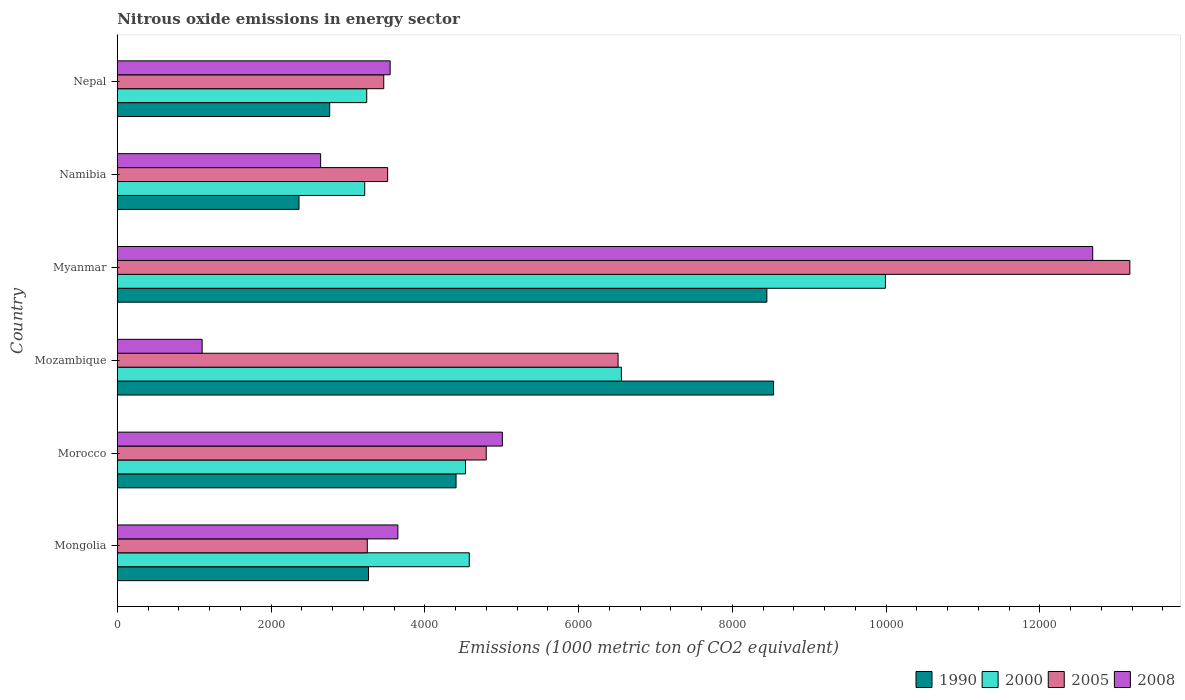How many different coloured bars are there?
Your answer should be very brief. 4. How many bars are there on the 3rd tick from the top?
Make the answer very short. 4. How many bars are there on the 5th tick from the bottom?
Make the answer very short. 4. What is the label of the 2nd group of bars from the top?
Provide a succinct answer. Namibia. What is the amount of nitrous oxide emitted in 1990 in Myanmar?
Make the answer very short. 8449.7. Across all countries, what is the maximum amount of nitrous oxide emitted in 2008?
Make the answer very short. 1.27e+04. Across all countries, what is the minimum amount of nitrous oxide emitted in 2008?
Provide a succinct answer. 1104.1. In which country was the amount of nitrous oxide emitted in 2000 maximum?
Give a very brief answer. Myanmar. In which country was the amount of nitrous oxide emitted in 2008 minimum?
Offer a terse response. Mozambique. What is the total amount of nitrous oxide emitted in 2008 in the graph?
Provide a short and direct response. 2.86e+04. What is the difference between the amount of nitrous oxide emitted in 2000 in Mongolia and that in Namibia?
Offer a very short reply. 1359.9. What is the difference between the amount of nitrous oxide emitted in 2008 in Myanmar and the amount of nitrous oxide emitted in 2005 in Nepal?
Your response must be concise. 9222.3. What is the average amount of nitrous oxide emitted in 2000 per country?
Your response must be concise. 5353.5. What is the difference between the amount of nitrous oxide emitted in 2000 and amount of nitrous oxide emitted in 1990 in Morocco?
Your answer should be very brief. 122.6. In how many countries, is the amount of nitrous oxide emitted in 1990 greater than 11600 1000 metric ton?
Give a very brief answer. 0. What is the ratio of the amount of nitrous oxide emitted in 1990 in Morocco to that in Myanmar?
Offer a terse response. 0.52. Is the amount of nitrous oxide emitted in 2000 in Morocco less than that in Namibia?
Your answer should be compact. No. What is the difference between the highest and the second highest amount of nitrous oxide emitted in 2005?
Your answer should be very brief. 6657.4. What is the difference between the highest and the lowest amount of nitrous oxide emitted in 2000?
Provide a succinct answer. 6773.5. In how many countries, is the amount of nitrous oxide emitted in 1990 greater than the average amount of nitrous oxide emitted in 1990 taken over all countries?
Make the answer very short. 2. Is it the case that in every country, the sum of the amount of nitrous oxide emitted in 2008 and amount of nitrous oxide emitted in 2005 is greater than the sum of amount of nitrous oxide emitted in 1990 and amount of nitrous oxide emitted in 2000?
Keep it short and to the point. No. What does the 2nd bar from the top in Mongolia represents?
Your answer should be compact. 2005. What does the 2nd bar from the bottom in Mozambique represents?
Give a very brief answer. 2000. How many bars are there?
Your response must be concise. 24. Are all the bars in the graph horizontal?
Offer a terse response. Yes. How many countries are there in the graph?
Provide a short and direct response. 6. What is the difference between two consecutive major ticks on the X-axis?
Your response must be concise. 2000. Are the values on the major ticks of X-axis written in scientific E-notation?
Provide a short and direct response. No. Does the graph contain grids?
Provide a succinct answer. No. Where does the legend appear in the graph?
Your answer should be compact. Bottom right. How are the legend labels stacked?
Offer a very short reply. Horizontal. What is the title of the graph?
Offer a very short reply. Nitrous oxide emissions in energy sector. Does "2001" appear as one of the legend labels in the graph?
Give a very brief answer. No. What is the label or title of the X-axis?
Keep it short and to the point. Emissions (1000 metric ton of CO2 equivalent). What is the label or title of the Y-axis?
Give a very brief answer. Country. What is the Emissions (1000 metric ton of CO2 equivalent) in 1990 in Mongolia?
Offer a very short reply. 3267.8. What is the Emissions (1000 metric ton of CO2 equivalent) in 2000 in Mongolia?
Ensure brevity in your answer.  4578.6. What is the Emissions (1000 metric ton of CO2 equivalent) of 2005 in Mongolia?
Ensure brevity in your answer.  3251.9. What is the Emissions (1000 metric ton of CO2 equivalent) in 2008 in Mongolia?
Provide a short and direct response. 3650.1. What is the Emissions (1000 metric ton of CO2 equivalent) of 1990 in Morocco?
Make the answer very short. 4406.9. What is the Emissions (1000 metric ton of CO2 equivalent) of 2000 in Morocco?
Give a very brief answer. 4529.5. What is the Emissions (1000 metric ton of CO2 equivalent) in 2005 in Morocco?
Keep it short and to the point. 4799.4. What is the Emissions (1000 metric ton of CO2 equivalent) of 2008 in Morocco?
Give a very brief answer. 5008.9. What is the Emissions (1000 metric ton of CO2 equivalent) in 1990 in Mozambique?
Make the answer very short. 8537. What is the Emissions (1000 metric ton of CO2 equivalent) of 2000 in Mozambique?
Provide a short and direct response. 6557.2. What is the Emissions (1000 metric ton of CO2 equivalent) of 2005 in Mozambique?
Your response must be concise. 6514.2. What is the Emissions (1000 metric ton of CO2 equivalent) of 2008 in Mozambique?
Keep it short and to the point. 1104.1. What is the Emissions (1000 metric ton of CO2 equivalent) of 1990 in Myanmar?
Provide a short and direct response. 8449.7. What is the Emissions (1000 metric ton of CO2 equivalent) in 2000 in Myanmar?
Keep it short and to the point. 9992.2. What is the Emissions (1000 metric ton of CO2 equivalent) in 2005 in Myanmar?
Make the answer very short. 1.32e+04. What is the Emissions (1000 metric ton of CO2 equivalent) of 2008 in Myanmar?
Provide a succinct answer. 1.27e+04. What is the Emissions (1000 metric ton of CO2 equivalent) of 1990 in Namibia?
Your answer should be compact. 2363.8. What is the Emissions (1000 metric ton of CO2 equivalent) of 2000 in Namibia?
Your answer should be compact. 3218.7. What is the Emissions (1000 metric ton of CO2 equivalent) of 2005 in Namibia?
Offer a terse response. 3516.8. What is the Emissions (1000 metric ton of CO2 equivalent) of 2008 in Namibia?
Provide a succinct answer. 2645.5. What is the Emissions (1000 metric ton of CO2 equivalent) of 1990 in Nepal?
Offer a very short reply. 2763. What is the Emissions (1000 metric ton of CO2 equivalent) in 2000 in Nepal?
Ensure brevity in your answer.  3244.8. What is the Emissions (1000 metric ton of CO2 equivalent) in 2005 in Nepal?
Your answer should be compact. 3466.2. What is the Emissions (1000 metric ton of CO2 equivalent) of 2008 in Nepal?
Your answer should be very brief. 3549.4. Across all countries, what is the maximum Emissions (1000 metric ton of CO2 equivalent) of 1990?
Your answer should be compact. 8537. Across all countries, what is the maximum Emissions (1000 metric ton of CO2 equivalent) in 2000?
Your answer should be compact. 9992.2. Across all countries, what is the maximum Emissions (1000 metric ton of CO2 equivalent) in 2005?
Provide a short and direct response. 1.32e+04. Across all countries, what is the maximum Emissions (1000 metric ton of CO2 equivalent) in 2008?
Your response must be concise. 1.27e+04. Across all countries, what is the minimum Emissions (1000 metric ton of CO2 equivalent) of 1990?
Make the answer very short. 2363.8. Across all countries, what is the minimum Emissions (1000 metric ton of CO2 equivalent) in 2000?
Give a very brief answer. 3218.7. Across all countries, what is the minimum Emissions (1000 metric ton of CO2 equivalent) of 2005?
Your response must be concise. 3251.9. Across all countries, what is the minimum Emissions (1000 metric ton of CO2 equivalent) in 2008?
Keep it short and to the point. 1104.1. What is the total Emissions (1000 metric ton of CO2 equivalent) in 1990 in the graph?
Give a very brief answer. 2.98e+04. What is the total Emissions (1000 metric ton of CO2 equivalent) in 2000 in the graph?
Provide a short and direct response. 3.21e+04. What is the total Emissions (1000 metric ton of CO2 equivalent) of 2005 in the graph?
Provide a succinct answer. 3.47e+04. What is the total Emissions (1000 metric ton of CO2 equivalent) of 2008 in the graph?
Give a very brief answer. 2.86e+04. What is the difference between the Emissions (1000 metric ton of CO2 equivalent) in 1990 in Mongolia and that in Morocco?
Your answer should be compact. -1139.1. What is the difference between the Emissions (1000 metric ton of CO2 equivalent) of 2000 in Mongolia and that in Morocco?
Your answer should be very brief. 49.1. What is the difference between the Emissions (1000 metric ton of CO2 equivalent) in 2005 in Mongolia and that in Morocco?
Offer a very short reply. -1547.5. What is the difference between the Emissions (1000 metric ton of CO2 equivalent) of 2008 in Mongolia and that in Morocco?
Offer a very short reply. -1358.8. What is the difference between the Emissions (1000 metric ton of CO2 equivalent) of 1990 in Mongolia and that in Mozambique?
Give a very brief answer. -5269.2. What is the difference between the Emissions (1000 metric ton of CO2 equivalent) of 2000 in Mongolia and that in Mozambique?
Offer a terse response. -1978.6. What is the difference between the Emissions (1000 metric ton of CO2 equivalent) of 2005 in Mongolia and that in Mozambique?
Give a very brief answer. -3262.3. What is the difference between the Emissions (1000 metric ton of CO2 equivalent) of 2008 in Mongolia and that in Mozambique?
Provide a succinct answer. 2546. What is the difference between the Emissions (1000 metric ton of CO2 equivalent) in 1990 in Mongolia and that in Myanmar?
Offer a terse response. -5181.9. What is the difference between the Emissions (1000 metric ton of CO2 equivalent) of 2000 in Mongolia and that in Myanmar?
Provide a succinct answer. -5413.6. What is the difference between the Emissions (1000 metric ton of CO2 equivalent) of 2005 in Mongolia and that in Myanmar?
Offer a very short reply. -9919.7. What is the difference between the Emissions (1000 metric ton of CO2 equivalent) of 2008 in Mongolia and that in Myanmar?
Keep it short and to the point. -9038.4. What is the difference between the Emissions (1000 metric ton of CO2 equivalent) in 1990 in Mongolia and that in Namibia?
Ensure brevity in your answer.  904. What is the difference between the Emissions (1000 metric ton of CO2 equivalent) of 2000 in Mongolia and that in Namibia?
Provide a short and direct response. 1359.9. What is the difference between the Emissions (1000 metric ton of CO2 equivalent) of 2005 in Mongolia and that in Namibia?
Your response must be concise. -264.9. What is the difference between the Emissions (1000 metric ton of CO2 equivalent) in 2008 in Mongolia and that in Namibia?
Ensure brevity in your answer.  1004.6. What is the difference between the Emissions (1000 metric ton of CO2 equivalent) of 1990 in Mongolia and that in Nepal?
Provide a succinct answer. 504.8. What is the difference between the Emissions (1000 metric ton of CO2 equivalent) of 2000 in Mongolia and that in Nepal?
Keep it short and to the point. 1333.8. What is the difference between the Emissions (1000 metric ton of CO2 equivalent) of 2005 in Mongolia and that in Nepal?
Keep it short and to the point. -214.3. What is the difference between the Emissions (1000 metric ton of CO2 equivalent) of 2008 in Mongolia and that in Nepal?
Keep it short and to the point. 100.7. What is the difference between the Emissions (1000 metric ton of CO2 equivalent) of 1990 in Morocco and that in Mozambique?
Make the answer very short. -4130.1. What is the difference between the Emissions (1000 metric ton of CO2 equivalent) in 2000 in Morocco and that in Mozambique?
Offer a very short reply. -2027.7. What is the difference between the Emissions (1000 metric ton of CO2 equivalent) of 2005 in Morocco and that in Mozambique?
Your answer should be very brief. -1714.8. What is the difference between the Emissions (1000 metric ton of CO2 equivalent) in 2008 in Morocco and that in Mozambique?
Keep it short and to the point. 3904.8. What is the difference between the Emissions (1000 metric ton of CO2 equivalent) of 1990 in Morocco and that in Myanmar?
Keep it short and to the point. -4042.8. What is the difference between the Emissions (1000 metric ton of CO2 equivalent) in 2000 in Morocco and that in Myanmar?
Keep it short and to the point. -5462.7. What is the difference between the Emissions (1000 metric ton of CO2 equivalent) in 2005 in Morocco and that in Myanmar?
Offer a very short reply. -8372.2. What is the difference between the Emissions (1000 metric ton of CO2 equivalent) of 2008 in Morocco and that in Myanmar?
Ensure brevity in your answer.  -7679.6. What is the difference between the Emissions (1000 metric ton of CO2 equivalent) in 1990 in Morocco and that in Namibia?
Ensure brevity in your answer.  2043.1. What is the difference between the Emissions (1000 metric ton of CO2 equivalent) in 2000 in Morocco and that in Namibia?
Your answer should be compact. 1310.8. What is the difference between the Emissions (1000 metric ton of CO2 equivalent) in 2005 in Morocco and that in Namibia?
Your answer should be compact. 1282.6. What is the difference between the Emissions (1000 metric ton of CO2 equivalent) of 2008 in Morocco and that in Namibia?
Offer a very short reply. 2363.4. What is the difference between the Emissions (1000 metric ton of CO2 equivalent) of 1990 in Morocco and that in Nepal?
Keep it short and to the point. 1643.9. What is the difference between the Emissions (1000 metric ton of CO2 equivalent) in 2000 in Morocco and that in Nepal?
Keep it short and to the point. 1284.7. What is the difference between the Emissions (1000 metric ton of CO2 equivalent) in 2005 in Morocco and that in Nepal?
Offer a very short reply. 1333.2. What is the difference between the Emissions (1000 metric ton of CO2 equivalent) in 2008 in Morocco and that in Nepal?
Your answer should be compact. 1459.5. What is the difference between the Emissions (1000 metric ton of CO2 equivalent) of 1990 in Mozambique and that in Myanmar?
Make the answer very short. 87.3. What is the difference between the Emissions (1000 metric ton of CO2 equivalent) in 2000 in Mozambique and that in Myanmar?
Give a very brief answer. -3435. What is the difference between the Emissions (1000 metric ton of CO2 equivalent) in 2005 in Mozambique and that in Myanmar?
Provide a succinct answer. -6657.4. What is the difference between the Emissions (1000 metric ton of CO2 equivalent) of 2008 in Mozambique and that in Myanmar?
Your answer should be compact. -1.16e+04. What is the difference between the Emissions (1000 metric ton of CO2 equivalent) of 1990 in Mozambique and that in Namibia?
Your response must be concise. 6173.2. What is the difference between the Emissions (1000 metric ton of CO2 equivalent) in 2000 in Mozambique and that in Namibia?
Your answer should be very brief. 3338.5. What is the difference between the Emissions (1000 metric ton of CO2 equivalent) of 2005 in Mozambique and that in Namibia?
Offer a very short reply. 2997.4. What is the difference between the Emissions (1000 metric ton of CO2 equivalent) of 2008 in Mozambique and that in Namibia?
Provide a short and direct response. -1541.4. What is the difference between the Emissions (1000 metric ton of CO2 equivalent) of 1990 in Mozambique and that in Nepal?
Offer a very short reply. 5774. What is the difference between the Emissions (1000 metric ton of CO2 equivalent) in 2000 in Mozambique and that in Nepal?
Keep it short and to the point. 3312.4. What is the difference between the Emissions (1000 metric ton of CO2 equivalent) of 2005 in Mozambique and that in Nepal?
Keep it short and to the point. 3048. What is the difference between the Emissions (1000 metric ton of CO2 equivalent) of 2008 in Mozambique and that in Nepal?
Offer a terse response. -2445.3. What is the difference between the Emissions (1000 metric ton of CO2 equivalent) in 1990 in Myanmar and that in Namibia?
Provide a succinct answer. 6085.9. What is the difference between the Emissions (1000 metric ton of CO2 equivalent) of 2000 in Myanmar and that in Namibia?
Offer a terse response. 6773.5. What is the difference between the Emissions (1000 metric ton of CO2 equivalent) of 2005 in Myanmar and that in Namibia?
Your answer should be compact. 9654.8. What is the difference between the Emissions (1000 metric ton of CO2 equivalent) in 2008 in Myanmar and that in Namibia?
Keep it short and to the point. 1.00e+04. What is the difference between the Emissions (1000 metric ton of CO2 equivalent) of 1990 in Myanmar and that in Nepal?
Your answer should be compact. 5686.7. What is the difference between the Emissions (1000 metric ton of CO2 equivalent) in 2000 in Myanmar and that in Nepal?
Your answer should be compact. 6747.4. What is the difference between the Emissions (1000 metric ton of CO2 equivalent) in 2005 in Myanmar and that in Nepal?
Offer a very short reply. 9705.4. What is the difference between the Emissions (1000 metric ton of CO2 equivalent) in 2008 in Myanmar and that in Nepal?
Offer a terse response. 9139.1. What is the difference between the Emissions (1000 metric ton of CO2 equivalent) in 1990 in Namibia and that in Nepal?
Give a very brief answer. -399.2. What is the difference between the Emissions (1000 metric ton of CO2 equivalent) of 2000 in Namibia and that in Nepal?
Your response must be concise. -26.1. What is the difference between the Emissions (1000 metric ton of CO2 equivalent) in 2005 in Namibia and that in Nepal?
Give a very brief answer. 50.6. What is the difference between the Emissions (1000 metric ton of CO2 equivalent) of 2008 in Namibia and that in Nepal?
Offer a very short reply. -903.9. What is the difference between the Emissions (1000 metric ton of CO2 equivalent) of 1990 in Mongolia and the Emissions (1000 metric ton of CO2 equivalent) of 2000 in Morocco?
Make the answer very short. -1261.7. What is the difference between the Emissions (1000 metric ton of CO2 equivalent) in 1990 in Mongolia and the Emissions (1000 metric ton of CO2 equivalent) in 2005 in Morocco?
Give a very brief answer. -1531.6. What is the difference between the Emissions (1000 metric ton of CO2 equivalent) of 1990 in Mongolia and the Emissions (1000 metric ton of CO2 equivalent) of 2008 in Morocco?
Your response must be concise. -1741.1. What is the difference between the Emissions (1000 metric ton of CO2 equivalent) in 2000 in Mongolia and the Emissions (1000 metric ton of CO2 equivalent) in 2005 in Morocco?
Keep it short and to the point. -220.8. What is the difference between the Emissions (1000 metric ton of CO2 equivalent) in 2000 in Mongolia and the Emissions (1000 metric ton of CO2 equivalent) in 2008 in Morocco?
Provide a succinct answer. -430.3. What is the difference between the Emissions (1000 metric ton of CO2 equivalent) in 2005 in Mongolia and the Emissions (1000 metric ton of CO2 equivalent) in 2008 in Morocco?
Your answer should be compact. -1757. What is the difference between the Emissions (1000 metric ton of CO2 equivalent) in 1990 in Mongolia and the Emissions (1000 metric ton of CO2 equivalent) in 2000 in Mozambique?
Keep it short and to the point. -3289.4. What is the difference between the Emissions (1000 metric ton of CO2 equivalent) of 1990 in Mongolia and the Emissions (1000 metric ton of CO2 equivalent) of 2005 in Mozambique?
Make the answer very short. -3246.4. What is the difference between the Emissions (1000 metric ton of CO2 equivalent) of 1990 in Mongolia and the Emissions (1000 metric ton of CO2 equivalent) of 2008 in Mozambique?
Offer a terse response. 2163.7. What is the difference between the Emissions (1000 metric ton of CO2 equivalent) in 2000 in Mongolia and the Emissions (1000 metric ton of CO2 equivalent) in 2005 in Mozambique?
Ensure brevity in your answer.  -1935.6. What is the difference between the Emissions (1000 metric ton of CO2 equivalent) in 2000 in Mongolia and the Emissions (1000 metric ton of CO2 equivalent) in 2008 in Mozambique?
Provide a succinct answer. 3474.5. What is the difference between the Emissions (1000 metric ton of CO2 equivalent) in 2005 in Mongolia and the Emissions (1000 metric ton of CO2 equivalent) in 2008 in Mozambique?
Your answer should be very brief. 2147.8. What is the difference between the Emissions (1000 metric ton of CO2 equivalent) of 1990 in Mongolia and the Emissions (1000 metric ton of CO2 equivalent) of 2000 in Myanmar?
Offer a terse response. -6724.4. What is the difference between the Emissions (1000 metric ton of CO2 equivalent) of 1990 in Mongolia and the Emissions (1000 metric ton of CO2 equivalent) of 2005 in Myanmar?
Offer a terse response. -9903.8. What is the difference between the Emissions (1000 metric ton of CO2 equivalent) of 1990 in Mongolia and the Emissions (1000 metric ton of CO2 equivalent) of 2008 in Myanmar?
Your answer should be very brief. -9420.7. What is the difference between the Emissions (1000 metric ton of CO2 equivalent) of 2000 in Mongolia and the Emissions (1000 metric ton of CO2 equivalent) of 2005 in Myanmar?
Give a very brief answer. -8593. What is the difference between the Emissions (1000 metric ton of CO2 equivalent) in 2000 in Mongolia and the Emissions (1000 metric ton of CO2 equivalent) in 2008 in Myanmar?
Your answer should be compact. -8109.9. What is the difference between the Emissions (1000 metric ton of CO2 equivalent) of 2005 in Mongolia and the Emissions (1000 metric ton of CO2 equivalent) of 2008 in Myanmar?
Keep it short and to the point. -9436.6. What is the difference between the Emissions (1000 metric ton of CO2 equivalent) of 1990 in Mongolia and the Emissions (1000 metric ton of CO2 equivalent) of 2000 in Namibia?
Keep it short and to the point. 49.1. What is the difference between the Emissions (1000 metric ton of CO2 equivalent) in 1990 in Mongolia and the Emissions (1000 metric ton of CO2 equivalent) in 2005 in Namibia?
Your response must be concise. -249. What is the difference between the Emissions (1000 metric ton of CO2 equivalent) of 1990 in Mongolia and the Emissions (1000 metric ton of CO2 equivalent) of 2008 in Namibia?
Your answer should be compact. 622.3. What is the difference between the Emissions (1000 metric ton of CO2 equivalent) in 2000 in Mongolia and the Emissions (1000 metric ton of CO2 equivalent) in 2005 in Namibia?
Your answer should be compact. 1061.8. What is the difference between the Emissions (1000 metric ton of CO2 equivalent) in 2000 in Mongolia and the Emissions (1000 metric ton of CO2 equivalent) in 2008 in Namibia?
Make the answer very short. 1933.1. What is the difference between the Emissions (1000 metric ton of CO2 equivalent) of 2005 in Mongolia and the Emissions (1000 metric ton of CO2 equivalent) of 2008 in Namibia?
Make the answer very short. 606.4. What is the difference between the Emissions (1000 metric ton of CO2 equivalent) in 1990 in Mongolia and the Emissions (1000 metric ton of CO2 equivalent) in 2000 in Nepal?
Offer a very short reply. 23. What is the difference between the Emissions (1000 metric ton of CO2 equivalent) of 1990 in Mongolia and the Emissions (1000 metric ton of CO2 equivalent) of 2005 in Nepal?
Provide a short and direct response. -198.4. What is the difference between the Emissions (1000 metric ton of CO2 equivalent) of 1990 in Mongolia and the Emissions (1000 metric ton of CO2 equivalent) of 2008 in Nepal?
Provide a short and direct response. -281.6. What is the difference between the Emissions (1000 metric ton of CO2 equivalent) in 2000 in Mongolia and the Emissions (1000 metric ton of CO2 equivalent) in 2005 in Nepal?
Provide a succinct answer. 1112.4. What is the difference between the Emissions (1000 metric ton of CO2 equivalent) in 2000 in Mongolia and the Emissions (1000 metric ton of CO2 equivalent) in 2008 in Nepal?
Provide a short and direct response. 1029.2. What is the difference between the Emissions (1000 metric ton of CO2 equivalent) of 2005 in Mongolia and the Emissions (1000 metric ton of CO2 equivalent) of 2008 in Nepal?
Give a very brief answer. -297.5. What is the difference between the Emissions (1000 metric ton of CO2 equivalent) in 1990 in Morocco and the Emissions (1000 metric ton of CO2 equivalent) in 2000 in Mozambique?
Ensure brevity in your answer.  -2150.3. What is the difference between the Emissions (1000 metric ton of CO2 equivalent) in 1990 in Morocco and the Emissions (1000 metric ton of CO2 equivalent) in 2005 in Mozambique?
Ensure brevity in your answer.  -2107.3. What is the difference between the Emissions (1000 metric ton of CO2 equivalent) in 1990 in Morocco and the Emissions (1000 metric ton of CO2 equivalent) in 2008 in Mozambique?
Your answer should be very brief. 3302.8. What is the difference between the Emissions (1000 metric ton of CO2 equivalent) in 2000 in Morocco and the Emissions (1000 metric ton of CO2 equivalent) in 2005 in Mozambique?
Offer a terse response. -1984.7. What is the difference between the Emissions (1000 metric ton of CO2 equivalent) in 2000 in Morocco and the Emissions (1000 metric ton of CO2 equivalent) in 2008 in Mozambique?
Ensure brevity in your answer.  3425.4. What is the difference between the Emissions (1000 metric ton of CO2 equivalent) in 2005 in Morocco and the Emissions (1000 metric ton of CO2 equivalent) in 2008 in Mozambique?
Give a very brief answer. 3695.3. What is the difference between the Emissions (1000 metric ton of CO2 equivalent) in 1990 in Morocco and the Emissions (1000 metric ton of CO2 equivalent) in 2000 in Myanmar?
Offer a very short reply. -5585.3. What is the difference between the Emissions (1000 metric ton of CO2 equivalent) of 1990 in Morocco and the Emissions (1000 metric ton of CO2 equivalent) of 2005 in Myanmar?
Make the answer very short. -8764.7. What is the difference between the Emissions (1000 metric ton of CO2 equivalent) of 1990 in Morocco and the Emissions (1000 metric ton of CO2 equivalent) of 2008 in Myanmar?
Keep it short and to the point. -8281.6. What is the difference between the Emissions (1000 metric ton of CO2 equivalent) of 2000 in Morocco and the Emissions (1000 metric ton of CO2 equivalent) of 2005 in Myanmar?
Your response must be concise. -8642.1. What is the difference between the Emissions (1000 metric ton of CO2 equivalent) of 2000 in Morocco and the Emissions (1000 metric ton of CO2 equivalent) of 2008 in Myanmar?
Give a very brief answer. -8159. What is the difference between the Emissions (1000 metric ton of CO2 equivalent) in 2005 in Morocco and the Emissions (1000 metric ton of CO2 equivalent) in 2008 in Myanmar?
Offer a terse response. -7889.1. What is the difference between the Emissions (1000 metric ton of CO2 equivalent) in 1990 in Morocco and the Emissions (1000 metric ton of CO2 equivalent) in 2000 in Namibia?
Your response must be concise. 1188.2. What is the difference between the Emissions (1000 metric ton of CO2 equivalent) of 1990 in Morocco and the Emissions (1000 metric ton of CO2 equivalent) of 2005 in Namibia?
Make the answer very short. 890.1. What is the difference between the Emissions (1000 metric ton of CO2 equivalent) in 1990 in Morocco and the Emissions (1000 metric ton of CO2 equivalent) in 2008 in Namibia?
Offer a terse response. 1761.4. What is the difference between the Emissions (1000 metric ton of CO2 equivalent) in 2000 in Morocco and the Emissions (1000 metric ton of CO2 equivalent) in 2005 in Namibia?
Ensure brevity in your answer.  1012.7. What is the difference between the Emissions (1000 metric ton of CO2 equivalent) in 2000 in Morocco and the Emissions (1000 metric ton of CO2 equivalent) in 2008 in Namibia?
Provide a succinct answer. 1884. What is the difference between the Emissions (1000 metric ton of CO2 equivalent) of 2005 in Morocco and the Emissions (1000 metric ton of CO2 equivalent) of 2008 in Namibia?
Offer a very short reply. 2153.9. What is the difference between the Emissions (1000 metric ton of CO2 equivalent) of 1990 in Morocco and the Emissions (1000 metric ton of CO2 equivalent) of 2000 in Nepal?
Offer a terse response. 1162.1. What is the difference between the Emissions (1000 metric ton of CO2 equivalent) of 1990 in Morocco and the Emissions (1000 metric ton of CO2 equivalent) of 2005 in Nepal?
Ensure brevity in your answer.  940.7. What is the difference between the Emissions (1000 metric ton of CO2 equivalent) in 1990 in Morocco and the Emissions (1000 metric ton of CO2 equivalent) in 2008 in Nepal?
Make the answer very short. 857.5. What is the difference between the Emissions (1000 metric ton of CO2 equivalent) of 2000 in Morocco and the Emissions (1000 metric ton of CO2 equivalent) of 2005 in Nepal?
Your answer should be compact. 1063.3. What is the difference between the Emissions (1000 metric ton of CO2 equivalent) of 2000 in Morocco and the Emissions (1000 metric ton of CO2 equivalent) of 2008 in Nepal?
Offer a terse response. 980.1. What is the difference between the Emissions (1000 metric ton of CO2 equivalent) of 2005 in Morocco and the Emissions (1000 metric ton of CO2 equivalent) of 2008 in Nepal?
Make the answer very short. 1250. What is the difference between the Emissions (1000 metric ton of CO2 equivalent) in 1990 in Mozambique and the Emissions (1000 metric ton of CO2 equivalent) in 2000 in Myanmar?
Provide a short and direct response. -1455.2. What is the difference between the Emissions (1000 metric ton of CO2 equivalent) of 1990 in Mozambique and the Emissions (1000 metric ton of CO2 equivalent) of 2005 in Myanmar?
Your answer should be very brief. -4634.6. What is the difference between the Emissions (1000 metric ton of CO2 equivalent) in 1990 in Mozambique and the Emissions (1000 metric ton of CO2 equivalent) in 2008 in Myanmar?
Make the answer very short. -4151.5. What is the difference between the Emissions (1000 metric ton of CO2 equivalent) of 2000 in Mozambique and the Emissions (1000 metric ton of CO2 equivalent) of 2005 in Myanmar?
Your answer should be compact. -6614.4. What is the difference between the Emissions (1000 metric ton of CO2 equivalent) of 2000 in Mozambique and the Emissions (1000 metric ton of CO2 equivalent) of 2008 in Myanmar?
Ensure brevity in your answer.  -6131.3. What is the difference between the Emissions (1000 metric ton of CO2 equivalent) of 2005 in Mozambique and the Emissions (1000 metric ton of CO2 equivalent) of 2008 in Myanmar?
Your answer should be compact. -6174.3. What is the difference between the Emissions (1000 metric ton of CO2 equivalent) of 1990 in Mozambique and the Emissions (1000 metric ton of CO2 equivalent) of 2000 in Namibia?
Give a very brief answer. 5318.3. What is the difference between the Emissions (1000 metric ton of CO2 equivalent) of 1990 in Mozambique and the Emissions (1000 metric ton of CO2 equivalent) of 2005 in Namibia?
Offer a very short reply. 5020.2. What is the difference between the Emissions (1000 metric ton of CO2 equivalent) of 1990 in Mozambique and the Emissions (1000 metric ton of CO2 equivalent) of 2008 in Namibia?
Keep it short and to the point. 5891.5. What is the difference between the Emissions (1000 metric ton of CO2 equivalent) in 2000 in Mozambique and the Emissions (1000 metric ton of CO2 equivalent) in 2005 in Namibia?
Offer a terse response. 3040.4. What is the difference between the Emissions (1000 metric ton of CO2 equivalent) in 2000 in Mozambique and the Emissions (1000 metric ton of CO2 equivalent) in 2008 in Namibia?
Your response must be concise. 3911.7. What is the difference between the Emissions (1000 metric ton of CO2 equivalent) of 2005 in Mozambique and the Emissions (1000 metric ton of CO2 equivalent) of 2008 in Namibia?
Offer a very short reply. 3868.7. What is the difference between the Emissions (1000 metric ton of CO2 equivalent) of 1990 in Mozambique and the Emissions (1000 metric ton of CO2 equivalent) of 2000 in Nepal?
Your response must be concise. 5292.2. What is the difference between the Emissions (1000 metric ton of CO2 equivalent) of 1990 in Mozambique and the Emissions (1000 metric ton of CO2 equivalent) of 2005 in Nepal?
Your answer should be very brief. 5070.8. What is the difference between the Emissions (1000 metric ton of CO2 equivalent) of 1990 in Mozambique and the Emissions (1000 metric ton of CO2 equivalent) of 2008 in Nepal?
Make the answer very short. 4987.6. What is the difference between the Emissions (1000 metric ton of CO2 equivalent) in 2000 in Mozambique and the Emissions (1000 metric ton of CO2 equivalent) in 2005 in Nepal?
Your response must be concise. 3091. What is the difference between the Emissions (1000 metric ton of CO2 equivalent) of 2000 in Mozambique and the Emissions (1000 metric ton of CO2 equivalent) of 2008 in Nepal?
Keep it short and to the point. 3007.8. What is the difference between the Emissions (1000 metric ton of CO2 equivalent) in 2005 in Mozambique and the Emissions (1000 metric ton of CO2 equivalent) in 2008 in Nepal?
Your response must be concise. 2964.8. What is the difference between the Emissions (1000 metric ton of CO2 equivalent) of 1990 in Myanmar and the Emissions (1000 metric ton of CO2 equivalent) of 2000 in Namibia?
Offer a terse response. 5231. What is the difference between the Emissions (1000 metric ton of CO2 equivalent) in 1990 in Myanmar and the Emissions (1000 metric ton of CO2 equivalent) in 2005 in Namibia?
Your answer should be compact. 4932.9. What is the difference between the Emissions (1000 metric ton of CO2 equivalent) of 1990 in Myanmar and the Emissions (1000 metric ton of CO2 equivalent) of 2008 in Namibia?
Offer a very short reply. 5804.2. What is the difference between the Emissions (1000 metric ton of CO2 equivalent) in 2000 in Myanmar and the Emissions (1000 metric ton of CO2 equivalent) in 2005 in Namibia?
Your answer should be very brief. 6475.4. What is the difference between the Emissions (1000 metric ton of CO2 equivalent) of 2000 in Myanmar and the Emissions (1000 metric ton of CO2 equivalent) of 2008 in Namibia?
Provide a succinct answer. 7346.7. What is the difference between the Emissions (1000 metric ton of CO2 equivalent) of 2005 in Myanmar and the Emissions (1000 metric ton of CO2 equivalent) of 2008 in Namibia?
Your answer should be very brief. 1.05e+04. What is the difference between the Emissions (1000 metric ton of CO2 equivalent) of 1990 in Myanmar and the Emissions (1000 metric ton of CO2 equivalent) of 2000 in Nepal?
Make the answer very short. 5204.9. What is the difference between the Emissions (1000 metric ton of CO2 equivalent) of 1990 in Myanmar and the Emissions (1000 metric ton of CO2 equivalent) of 2005 in Nepal?
Keep it short and to the point. 4983.5. What is the difference between the Emissions (1000 metric ton of CO2 equivalent) of 1990 in Myanmar and the Emissions (1000 metric ton of CO2 equivalent) of 2008 in Nepal?
Provide a short and direct response. 4900.3. What is the difference between the Emissions (1000 metric ton of CO2 equivalent) of 2000 in Myanmar and the Emissions (1000 metric ton of CO2 equivalent) of 2005 in Nepal?
Ensure brevity in your answer.  6526. What is the difference between the Emissions (1000 metric ton of CO2 equivalent) in 2000 in Myanmar and the Emissions (1000 metric ton of CO2 equivalent) in 2008 in Nepal?
Your response must be concise. 6442.8. What is the difference between the Emissions (1000 metric ton of CO2 equivalent) in 2005 in Myanmar and the Emissions (1000 metric ton of CO2 equivalent) in 2008 in Nepal?
Your answer should be very brief. 9622.2. What is the difference between the Emissions (1000 metric ton of CO2 equivalent) of 1990 in Namibia and the Emissions (1000 metric ton of CO2 equivalent) of 2000 in Nepal?
Ensure brevity in your answer.  -881. What is the difference between the Emissions (1000 metric ton of CO2 equivalent) in 1990 in Namibia and the Emissions (1000 metric ton of CO2 equivalent) in 2005 in Nepal?
Your response must be concise. -1102.4. What is the difference between the Emissions (1000 metric ton of CO2 equivalent) in 1990 in Namibia and the Emissions (1000 metric ton of CO2 equivalent) in 2008 in Nepal?
Offer a terse response. -1185.6. What is the difference between the Emissions (1000 metric ton of CO2 equivalent) in 2000 in Namibia and the Emissions (1000 metric ton of CO2 equivalent) in 2005 in Nepal?
Your answer should be very brief. -247.5. What is the difference between the Emissions (1000 metric ton of CO2 equivalent) of 2000 in Namibia and the Emissions (1000 metric ton of CO2 equivalent) of 2008 in Nepal?
Provide a short and direct response. -330.7. What is the difference between the Emissions (1000 metric ton of CO2 equivalent) of 2005 in Namibia and the Emissions (1000 metric ton of CO2 equivalent) of 2008 in Nepal?
Offer a terse response. -32.6. What is the average Emissions (1000 metric ton of CO2 equivalent) in 1990 per country?
Provide a succinct answer. 4964.7. What is the average Emissions (1000 metric ton of CO2 equivalent) in 2000 per country?
Give a very brief answer. 5353.5. What is the average Emissions (1000 metric ton of CO2 equivalent) in 2005 per country?
Make the answer very short. 5786.68. What is the average Emissions (1000 metric ton of CO2 equivalent) of 2008 per country?
Make the answer very short. 4774.42. What is the difference between the Emissions (1000 metric ton of CO2 equivalent) of 1990 and Emissions (1000 metric ton of CO2 equivalent) of 2000 in Mongolia?
Ensure brevity in your answer.  -1310.8. What is the difference between the Emissions (1000 metric ton of CO2 equivalent) in 1990 and Emissions (1000 metric ton of CO2 equivalent) in 2005 in Mongolia?
Give a very brief answer. 15.9. What is the difference between the Emissions (1000 metric ton of CO2 equivalent) of 1990 and Emissions (1000 metric ton of CO2 equivalent) of 2008 in Mongolia?
Give a very brief answer. -382.3. What is the difference between the Emissions (1000 metric ton of CO2 equivalent) of 2000 and Emissions (1000 metric ton of CO2 equivalent) of 2005 in Mongolia?
Keep it short and to the point. 1326.7. What is the difference between the Emissions (1000 metric ton of CO2 equivalent) of 2000 and Emissions (1000 metric ton of CO2 equivalent) of 2008 in Mongolia?
Keep it short and to the point. 928.5. What is the difference between the Emissions (1000 metric ton of CO2 equivalent) of 2005 and Emissions (1000 metric ton of CO2 equivalent) of 2008 in Mongolia?
Make the answer very short. -398.2. What is the difference between the Emissions (1000 metric ton of CO2 equivalent) of 1990 and Emissions (1000 metric ton of CO2 equivalent) of 2000 in Morocco?
Ensure brevity in your answer.  -122.6. What is the difference between the Emissions (1000 metric ton of CO2 equivalent) of 1990 and Emissions (1000 metric ton of CO2 equivalent) of 2005 in Morocco?
Provide a succinct answer. -392.5. What is the difference between the Emissions (1000 metric ton of CO2 equivalent) in 1990 and Emissions (1000 metric ton of CO2 equivalent) in 2008 in Morocco?
Provide a short and direct response. -602. What is the difference between the Emissions (1000 metric ton of CO2 equivalent) in 2000 and Emissions (1000 metric ton of CO2 equivalent) in 2005 in Morocco?
Provide a short and direct response. -269.9. What is the difference between the Emissions (1000 metric ton of CO2 equivalent) of 2000 and Emissions (1000 metric ton of CO2 equivalent) of 2008 in Morocco?
Offer a very short reply. -479.4. What is the difference between the Emissions (1000 metric ton of CO2 equivalent) of 2005 and Emissions (1000 metric ton of CO2 equivalent) of 2008 in Morocco?
Offer a very short reply. -209.5. What is the difference between the Emissions (1000 metric ton of CO2 equivalent) in 1990 and Emissions (1000 metric ton of CO2 equivalent) in 2000 in Mozambique?
Make the answer very short. 1979.8. What is the difference between the Emissions (1000 metric ton of CO2 equivalent) of 1990 and Emissions (1000 metric ton of CO2 equivalent) of 2005 in Mozambique?
Ensure brevity in your answer.  2022.8. What is the difference between the Emissions (1000 metric ton of CO2 equivalent) of 1990 and Emissions (1000 metric ton of CO2 equivalent) of 2008 in Mozambique?
Make the answer very short. 7432.9. What is the difference between the Emissions (1000 metric ton of CO2 equivalent) of 2000 and Emissions (1000 metric ton of CO2 equivalent) of 2005 in Mozambique?
Your answer should be very brief. 43. What is the difference between the Emissions (1000 metric ton of CO2 equivalent) in 2000 and Emissions (1000 metric ton of CO2 equivalent) in 2008 in Mozambique?
Provide a succinct answer. 5453.1. What is the difference between the Emissions (1000 metric ton of CO2 equivalent) of 2005 and Emissions (1000 metric ton of CO2 equivalent) of 2008 in Mozambique?
Offer a terse response. 5410.1. What is the difference between the Emissions (1000 metric ton of CO2 equivalent) in 1990 and Emissions (1000 metric ton of CO2 equivalent) in 2000 in Myanmar?
Provide a succinct answer. -1542.5. What is the difference between the Emissions (1000 metric ton of CO2 equivalent) of 1990 and Emissions (1000 metric ton of CO2 equivalent) of 2005 in Myanmar?
Ensure brevity in your answer.  -4721.9. What is the difference between the Emissions (1000 metric ton of CO2 equivalent) in 1990 and Emissions (1000 metric ton of CO2 equivalent) in 2008 in Myanmar?
Provide a short and direct response. -4238.8. What is the difference between the Emissions (1000 metric ton of CO2 equivalent) of 2000 and Emissions (1000 metric ton of CO2 equivalent) of 2005 in Myanmar?
Ensure brevity in your answer.  -3179.4. What is the difference between the Emissions (1000 metric ton of CO2 equivalent) in 2000 and Emissions (1000 metric ton of CO2 equivalent) in 2008 in Myanmar?
Your response must be concise. -2696.3. What is the difference between the Emissions (1000 metric ton of CO2 equivalent) in 2005 and Emissions (1000 metric ton of CO2 equivalent) in 2008 in Myanmar?
Ensure brevity in your answer.  483.1. What is the difference between the Emissions (1000 metric ton of CO2 equivalent) in 1990 and Emissions (1000 metric ton of CO2 equivalent) in 2000 in Namibia?
Your response must be concise. -854.9. What is the difference between the Emissions (1000 metric ton of CO2 equivalent) of 1990 and Emissions (1000 metric ton of CO2 equivalent) of 2005 in Namibia?
Your answer should be compact. -1153. What is the difference between the Emissions (1000 metric ton of CO2 equivalent) in 1990 and Emissions (1000 metric ton of CO2 equivalent) in 2008 in Namibia?
Give a very brief answer. -281.7. What is the difference between the Emissions (1000 metric ton of CO2 equivalent) in 2000 and Emissions (1000 metric ton of CO2 equivalent) in 2005 in Namibia?
Give a very brief answer. -298.1. What is the difference between the Emissions (1000 metric ton of CO2 equivalent) in 2000 and Emissions (1000 metric ton of CO2 equivalent) in 2008 in Namibia?
Your response must be concise. 573.2. What is the difference between the Emissions (1000 metric ton of CO2 equivalent) of 2005 and Emissions (1000 metric ton of CO2 equivalent) of 2008 in Namibia?
Ensure brevity in your answer.  871.3. What is the difference between the Emissions (1000 metric ton of CO2 equivalent) in 1990 and Emissions (1000 metric ton of CO2 equivalent) in 2000 in Nepal?
Ensure brevity in your answer.  -481.8. What is the difference between the Emissions (1000 metric ton of CO2 equivalent) in 1990 and Emissions (1000 metric ton of CO2 equivalent) in 2005 in Nepal?
Provide a short and direct response. -703.2. What is the difference between the Emissions (1000 metric ton of CO2 equivalent) in 1990 and Emissions (1000 metric ton of CO2 equivalent) in 2008 in Nepal?
Keep it short and to the point. -786.4. What is the difference between the Emissions (1000 metric ton of CO2 equivalent) in 2000 and Emissions (1000 metric ton of CO2 equivalent) in 2005 in Nepal?
Offer a terse response. -221.4. What is the difference between the Emissions (1000 metric ton of CO2 equivalent) of 2000 and Emissions (1000 metric ton of CO2 equivalent) of 2008 in Nepal?
Ensure brevity in your answer.  -304.6. What is the difference between the Emissions (1000 metric ton of CO2 equivalent) in 2005 and Emissions (1000 metric ton of CO2 equivalent) in 2008 in Nepal?
Give a very brief answer. -83.2. What is the ratio of the Emissions (1000 metric ton of CO2 equivalent) in 1990 in Mongolia to that in Morocco?
Make the answer very short. 0.74. What is the ratio of the Emissions (1000 metric ton of CO2 equivalent) of 2000 in Mongolia to that in Morocco?
Your response must be concise. 1.01. What is the ratio of the Emissions (1000 metric ton of CO2 equivalent) of 2005 in Mongolia to that in Morocco?
Offer a terse response. 0.68. What is the ratio of the Emissions (1000 metric ton of CO2 equivalent) in 2008 in Mongolia to that in Morocco?
Offer a terse response. 0.73. What is the ratio of the Emissions (1000 metric ton of CO2 equivalent) in 1990 in Mongolia to that in Mozambique?
Offer a terse response. 0.38. What is the ratio of the Emissions (1000 metric ton of CO2 equivalent) of 2000 in Mongolia to that in Mozambique?
Keep it short and to the point. 0.7. What is the ratio of the Emissions (1000 metric ton of CO2 equivalent) of 2005 in Mongolia to that in Mozambique?
Give a very brief answer. 0.5. What is the ratio of the Emissions (1000 metric ton of CO2 equivalent) of 2008 in Mongolia to that in Mozambique?
Make the answer very short. 3.31. What is the ratio of the Emissions (1000 metric ton of CO2 equivalent) in 1990 in Mongolia to that in Myanmar?
Offer a terse response. 0.39. What is the ratio of the Emissions (1000 metric ton of CO2 equivalent) of 2000 in Mongolia to that in Myanmar?
Your answer should be very brief. 0.46. What is the ratio of the Emissions (1000 metric ton of CO2 equivalent) of 2005 in Mongolia to that in Myanmar?
Provide a short and direct response. 0.25. What is the ratio of the Emissions (1000 metric ton of CO2 equivalent) in 2008 in Mongolia to that in Myanmar?
Make the answer very short. 0.29. What is the ratio of the Emissions (1000 metric ton of CO2 equivalent) in 1990 in Mongolia to that in Namibia?
Ensure brevity in your answer.  1.38. What is the ratio of the Emissions (1000 metric ton of CO2 equivalent) in 2000 in Mongolia to that in Namibia?
Your answer should be compact. 1.42. What is the ratio of the Emissions (1000 metric ton of CO2 equivalent) of 2005 in Mongolia to that in Namibia?
Give a very brief answer. 0.92. What is the ratio of the Emissions (1000 metric ton of CO2 equivalent) of 2008 in Mongolia to that in Namibia?
Provide a short and direct response. 1.38. What is the ratio of the Emissions (1000 metric ton of CO2 equivalent) of 1990 in Mongolia to that in Nepal?
Your response must be concise. 1.18. What is the ratio of the Emissions (1000 metric ton of CO2 equivalent) of 2000 in Mongolia to that in Nepal?
Provide a short and direct response. 1.41. What is the ratio of the Emissions (1000 metric ton of CO2 equivalent) of 2005 in Mongolia to that in Nepal?
Offer a terse response. 0.94. What is the ratio of the Emissions (1000 metric ton of CO2 equivalent) in 2008 in Mongolia to that in Nepal?
Offer a very short reply. 1.03. What is the ratio of the Emissions (1000 metric ton of CO2 equivalent) in 1990 in Morocco to that in Mozambique?
Ensure brevity in your answer.  0.52. What is the ratio of the Emissions (1000 metric ton of CO2 equivalent) in 2000 in Morocco to that in Mozambique?
Keep it short and to the point. 0.69. What is the ratio of the Emissions (1000 metric ton of CO2 equivalent) in 2005 in Morocco to that in Mozambique?
Offer a terse response. 0.74. What is the ratio of the Emissions (1000 metric ton of CO2 equivalent) of 2008 in Morocco to that in Mozambique?
Give a very brief answer. 4.54. What is the ratio of the Emissions (1000 metric ton of CO2 equivalent) of 1990 in Morocco to that in Myanmar?
Provide a short and direct response. 0.52. What is the ratio of the Emissions (1000 metric ton of CO2 equivalent) of 2000 in Morocco to that in Myanmar?
Keep it short and to the point. 0.45. What is the ratio of the Emissions (1000 metric ton of CO2 equivalent) of 2005 in Morocco to that in Myanmar?
Ensure brevity in your answer.  0.36. What is the ratio of the Emissions (1000 metric ton of CO2 equivalent) in 2008 in Morocco to that in Myanmar?
Ensure brevity in your answer.  0.39. What is the ratio of the Emissions (1000 metric ton of CO2 equivalent) of 1990 in Morocco to that in Namibia?
Make the answer very short. 1.86. What is the ratio of the Emissions (1000 metric ton of CO2 equivalent) in 2000 in Morocco to that in Namibia?
Keep it short and to the point. 1.41. What is the ratio of the Emissions (1000 metric ton of CO2 equivalent) of 2005 in Morocco to that in Namibia?
Keep it short and to the point. 1.36. What is the ratio of the Emissions (1000 metric ton of CO2 equivalent) in 2008 in Morocco to that in Namibia?
Offer a terse response. 1.89. What is the ratio of the Emissions (1000 metric ton of CO2 equivalent) of 1990 in Morocco to that in Nepal?
Provide a succinct answer. 1.59. What is the ratio of the Emissions (1000 metric ton of CO2 equivalent) of 2000 in Morocco to that in Nepal?
Ensure brevity in your answer.  1.4. What is the ratio of the Emissions (1000 metric ton of CO2 equivalent) in 2005 in Morocco to that in Nepal?
Your response must be concise. 1.38. What is the ratio of the Emissions (1000 metric ton of CO2 equivalent) in 2008 in Morocco to that in Nepal?
Keep it short and to the point. 1.41. What is the ratio of the Emissions (1000 metric ton of CO2 equivalent) of 1990 in Mozambique to that in Myanmar?
Ensure brevity in your answer.  1.01. What is the ratio of the Emissions (1000 metric ton of CO2 equivalent) in 2000 in Mozambique to that in Myanmar?
Your answer should be very brief. 0.66. What is the ratio of the Emissions (1000 metric ton of CO2 equivalent) in 2005 in Mozambique to that in Myanmar?
Offer a very short reply. 0.49. What is the ratio of the Emissions (1000 metric ton of CO2 equivalent) of 2008 in Mozambique to that in Myanmar?
Make the answer very short. 0.09. What is the ratio of the Emissions (1000 metric ton of CO2 equivalent) of 1990 in Mozambique to that in Namibia?
Your answer should be very brief. 3.61. What is the ratio of the Emissions (1000 metric ton of CO2 equivalent) in 2000 in Mozambique to that in Namibia?
Your answer should be very brief. 2.04. What is the ratio of the Emissions (1000 metric ton of CO2 equivalent) of 2005 in Mozambique to that in Namibia?
Your answer should be compact. 1.85. What is the ratio of the Emissions (1000 metric ton of CO2 equivalent) of 2008 in Mozambique to that in Namibia?
Offer a very short reply. 0.42. What is the ratio of the Emissions (1000 metric ton of CO2 equivalent) of 1990 in Mozambique to that in Nepal?
Ensure brevity in your answer.  3.09. What is the ratio of the Emissions (1000 metric ton of CO2 equivalent) in 2000 in Mozambique to that in Nepal?
Your answer should be compact. 2.02. What is the ratio of the Emissions (1000 metric ton of CO2 equivalent) of 2005 in Mozambique to that in Nepal?
Keep it short and to the point. 1.88. What is the ratio of the Emissions (1000 metric ton of CO2 equivalent) in 2008 in Mozambique to that in Nepal?
Your response must be concise. 0.31. What is the ratio of the Emissions (1000 metric ton of CO2 equivalent) of 1990 in Myanmar to that in Namibia?
Give a very brief answer. 3.57. What is the ratio of the Emissions (1000 metric ton of CO2 equivalent) of 2000 in Myanmar to that in Namibia?
Make the answer very short. 3.1. What is the ratio of the Emissions (1000 metric ton of CO2 equivalent) in 2005 in Myanmar to that in Namibia?
Offer a terse response. 3.75. What is the ratio of the Emissions (1000 metric ton of CO2 equivalent) in 2008 in Myanmar to that in Namibia?
Offer a terse response. 4.8. What is the ratio of the Emissions (1000 metric ton of CO2 equivalent) in 1990 in Myanmar to that in Nepal?
Your answer should be very brief. 3.06. What is the ratio of the Emissions (1000 metric ton of CO2 equivalent) of 2000 in Myanmar to that in Nepal?
Keep it short and to the point. 3.08. What is the ratio of the Emissions (1000 metric ton of CO2 equivalent) in 2005 in Myanmar to that in Nepal?
Give a very brief answer. 3.8. What is the ratio of the Emissions (1000 metric ton of CO2 equivalent) in 2008 in Myanmar to that in Nepal?
Provide a succinct answer. 3.57. What is the ratio of the Emissions (1000 metric ton of CO2 equivalent) in 1990 in Namibia to that in Nepal?
Offer a terse response. 0.86. What is the ratio of the Emissions (1000 metric ton of CO2 equivalent) in 2000 in Namibia to that in Nepal?
Offer a very short reply. 0.99. What is the ratio of the Emissions (1000 metric ton of CO2 equivalent) in 2005 in Namibia to that in Nepal?
Keep it short and to the point. 1.01. What is the ratio of the Emissions (1000 metric ton of CO2 equivalent) of 2008 in Namibia to that in Nepal?
Give a very brief answer. 0.75. What is the difference between the highest and the second highest Emissions (1000 metric ton of CO2 equivalent) in 1990?
Offer a terse response. 87.3. What is the difference between the highest and the second highest Emissions (1000 metric ton of CO2 equivalent) of 2000?
Ensure brevity in your answer.  3435. What is the difference between the highest and the second highest Emissions (1000 metric ton of CO2 equivalent) of 2005?
Provide a short and direct response. 6657.4. What is the difference between the highest and the second highest Emissions (1000 metric ton of CO2 equivalent) of 2008?
Give a very brief answer. 7679.6. What is the difference between the highest and the lowest Emissions (1000 metric ton of CO2 equivalent) of 1990?
Provide a succinct answer. 6173.2. What is the difference between the highest and the lowest Emissions (1000 metric ton of CO2 equivalent) of 2000?
Make the answer very short. 6773.5. What is the difference between the highest and the lowest Emissions (1000 metric ton of CO2 equivalent) of 2005?
Give a very brief answer. 9919.7. What is the difference between the highest and the lowest Emissions (1000 metric ton of CO2 equivalent) in 2008?
Keep it short and to the point. 1.16e+04. 